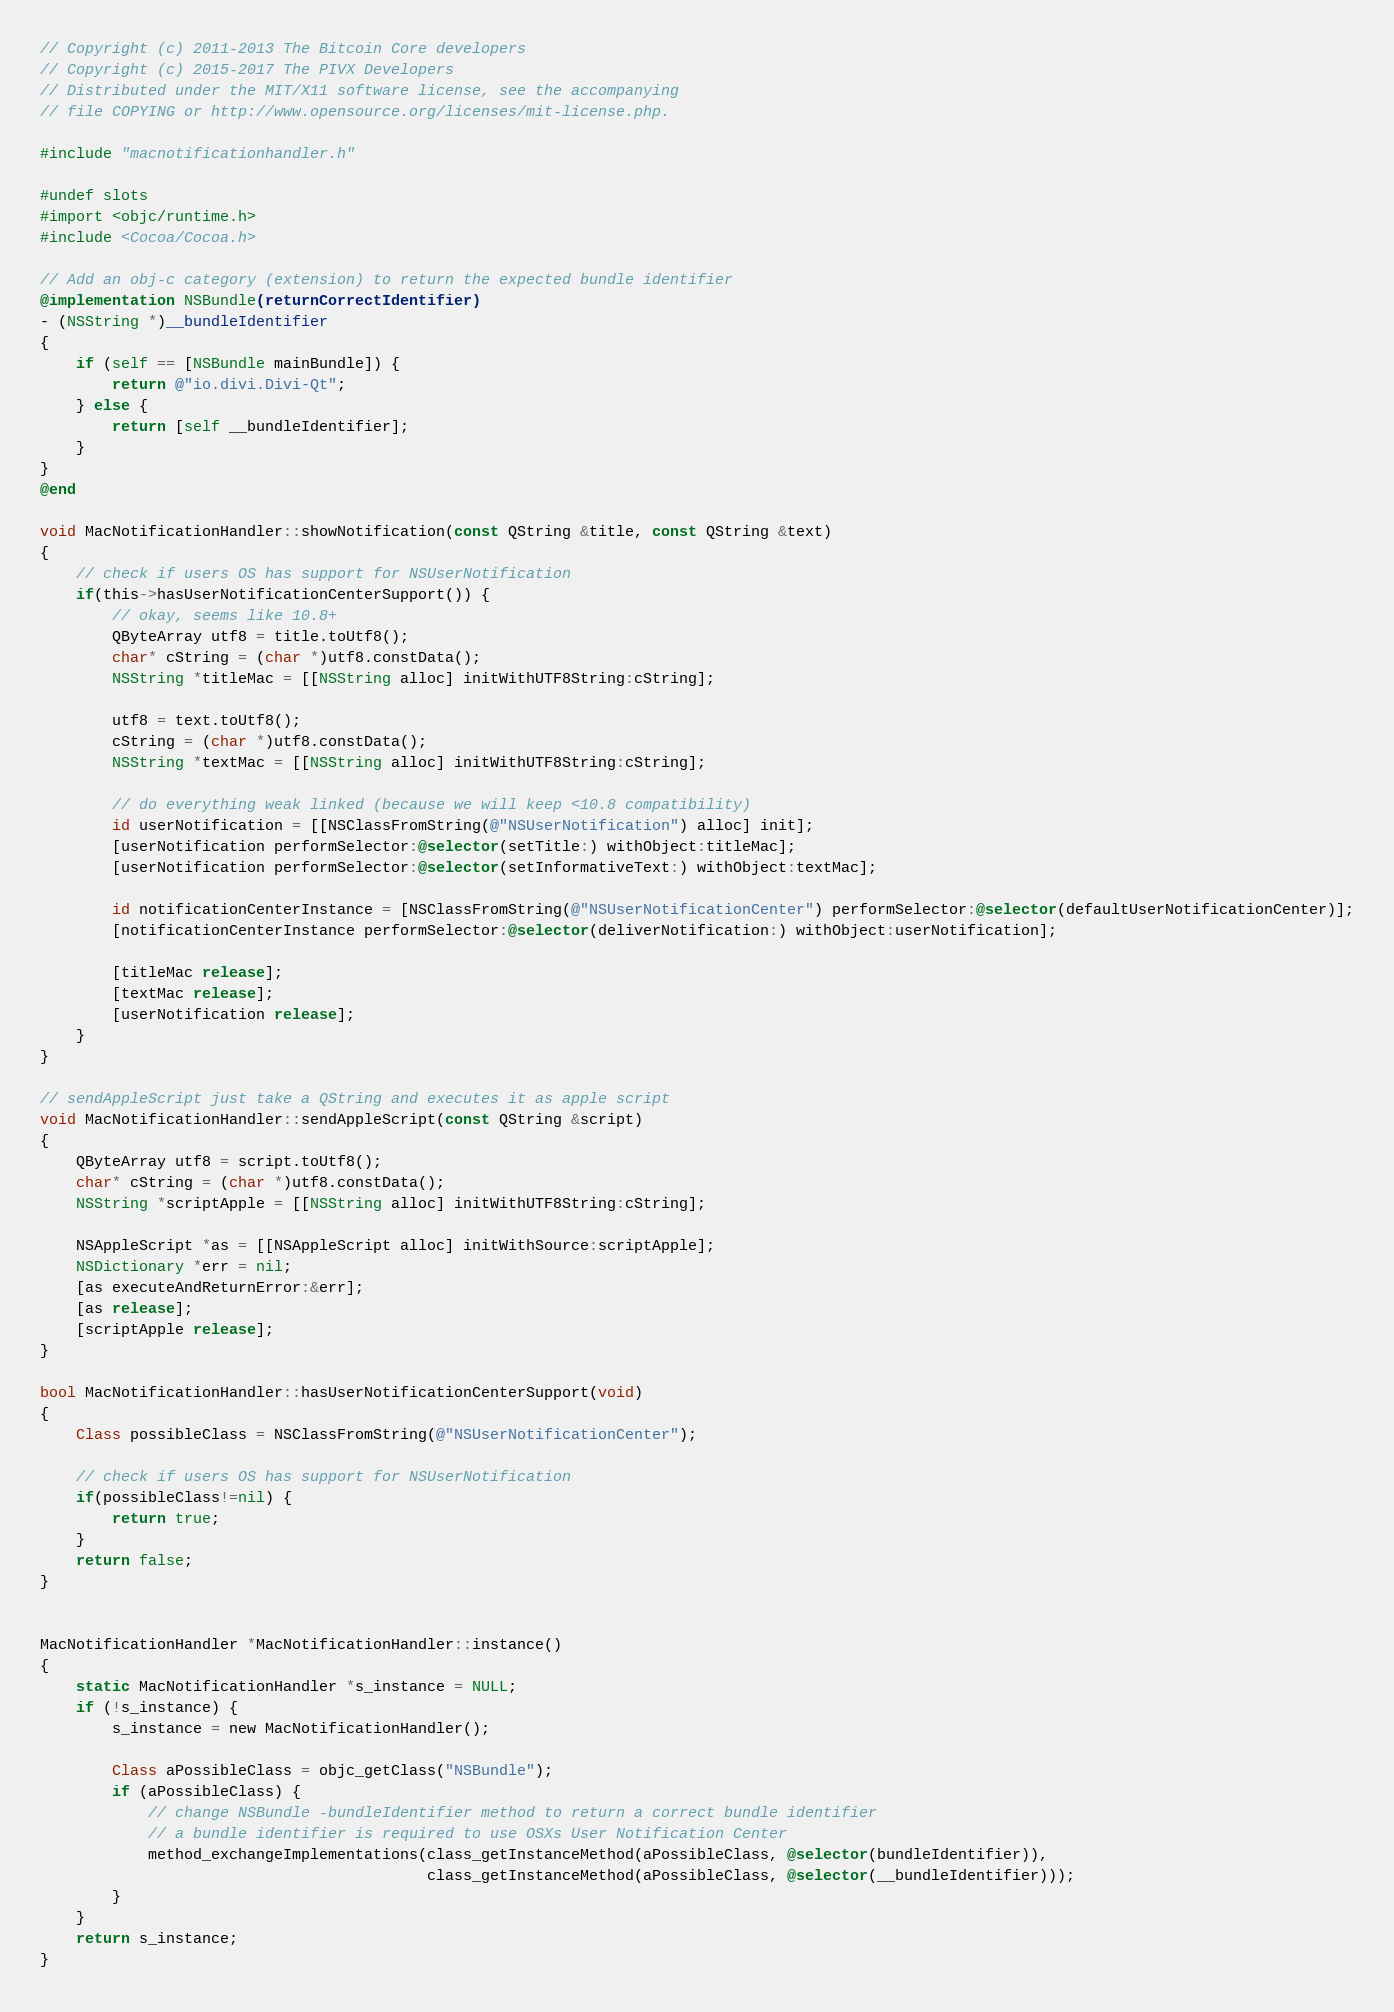<code> <loc_0><loc_0><loc_500><loc_500><_ObjectiveC_>// Copyright (c) 2011-2013 The Bitcoin Core developers
// Copyright (c) 2015-2017 The PIVX Developers
// Distributed under the MIT/X11 software license, see the accompanying
// file COPYING or http://www.opensource.org/licenses/mit-license.php.

#include "macnotificationhandler.h"

#undef slots
#import <objc/runtime.h>
#include <Cocoa/Cocoa.h>

// Add an obj-c category (extension) to return the expected bundle identifier
@implementation NSBundle(returnCorrectIdentifier)
- (NSString *)__bundleIdentifier
{
    if (self == [NSBundle mainBundle]) {
        return @"io.divi.Divi-Qt";
    } else {
        return [self __bundleIdentifier];
    }
}
@end

void MacNotificationHandler::showNotification(const QString &title, const QString &text)
{
    // check if users OS has support for NSUserNotification
    if(this->hasUserNotificationCenterSupport()) {
        // okay, seems like 10.8+
        QByteArray utf8 = title.toUtf8();
        char* cString = (char *)utf8.constData();
        NSString *titleMac = [[NSString alloc] initWithUTF8String:cString];

        utf8 = text.toUtf8();
        cString = (char *)utf8.constData();
        NSString *textMac = [[NSString alloc] initWithUTF8String:cString];

        // do everything weak linked (because we will keep <10.8 compatibility)
        id userNotification = [[NSClassFromString(@"NSUserNotification") alloc] init];
        [userNotification performSelector:@selector(setTitle:) withObject:titleMac];
        [userNotification performSelector:@selector(setInformativeText:) withObject:textMac];

        id notificationCenterInstance = [NSClassFromString(@"NSUserNotificationCenter") performSelector:@selector(defaultUserNotificationCenter)];
        [notificationCenterInstance performSelector:@selector(deliverNotification:) withObject:userNotification];

        [titleMac release];
        [textMac release];
        [userNotification release];
    }
}

// sendAppleScript just take a QString and executes it as apple script
void MacNotificationHandler::sendAppleScript(const QString &script)
{
    QByteArray utf8 = script.toUtf8();
    char* cString = (char *)utf8.constData();
    NSString *scriptApple = [[NSString alloc] initWithUTF8String:cString];

    NSAppleScript *as = [[NSAppleScript alloc] initWithSource:scriptApple];
    NSDictionary *err = nil;
    [as executeAndReturnError:&err];
    [as release];
    [scriptApple release];
}

bool MacNotificationHandler::hasUserNotificationCenterSupport(void)
{
    Class possibleClass = NSClassFromString(@"NSUserNotificationCenter");

    // check if users OS has support for NSUserNotification
    if(possibleClass!=nil) {
        return true;
    }
    return false;
}


MacNotificationHandler *MacNotificationHandler::instance()
{
    static MacNotificationHandler *s_instance = NULL;
    if (!s_instance) {
        s_instance = new MacNotificationHandler();
        
        Class aPossibleClass = objc_getClass("NSBundle");
        if (aPossibleClass) {
            // change NSBundle -bundleIdentifier method to return a correct bundle identifier
            // a bundle identifier is required to use OSXs User Notification Center
            method_exchangeImplementations(class_getInstanceMethod(aPossibleClass, @selector(bundleIdentifier)),
                                           class_getInstanceMethod(aPossibleClass, @selector(__bundleIdentifier)));
        }
    }
    return s_instance;
}
</code> 